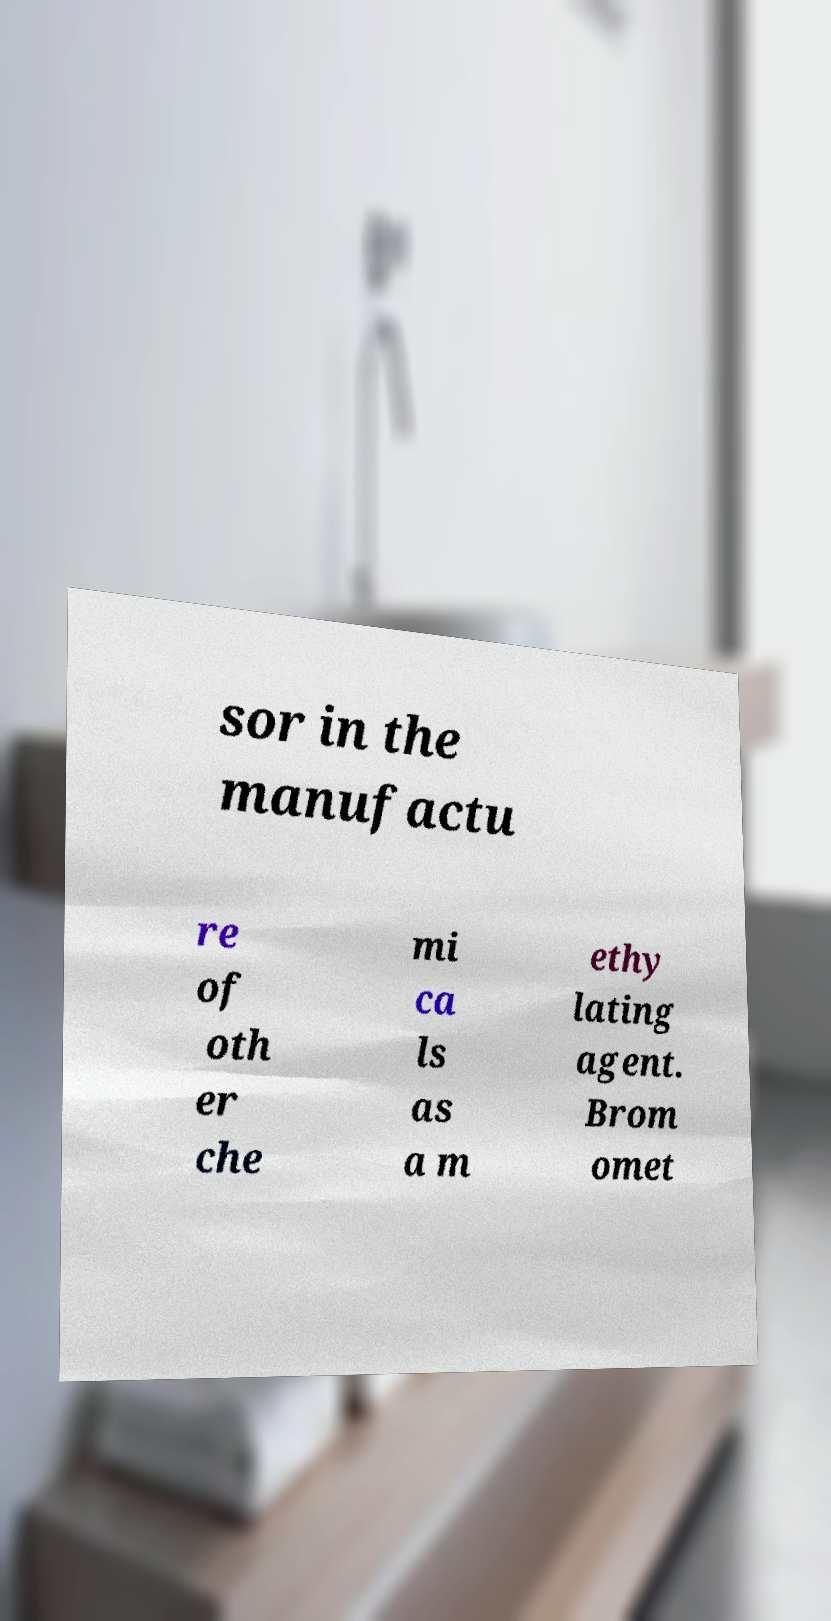There's text embedded in this image that I need extracted. Can you transcribe it verbatim? sor in the manufactu re of oth er che mi ca ls as a m ethy lating agent. Brom omet 